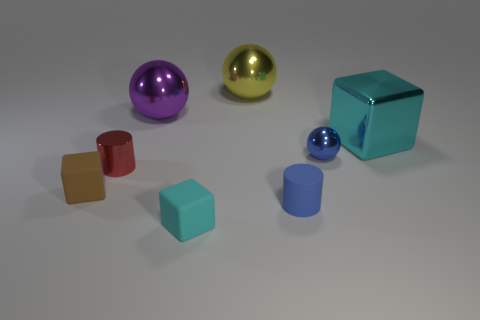Add 1 purple metal spheres. How many objects exist? 9 Subtract all spheres. How many objects are left? 5 Subtract all small cyan balls. Subtract all tiny brown matte objects. How many objects are left? 7 Add 1 cylinders. How many cylinders are left? 3 Add 4 brown blocks. How many brown blocks exist? 5 Subtract 0 cyan spheres. How many objects are left? 8 